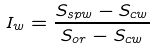Convert formula to latex. <formula><loc_0><loc_0><loc_500><loc_500>I _ { w } = \frac { S _ { s p w } - S _ { c w } } { S _ { o r } - S _ { c w } }</formula> 